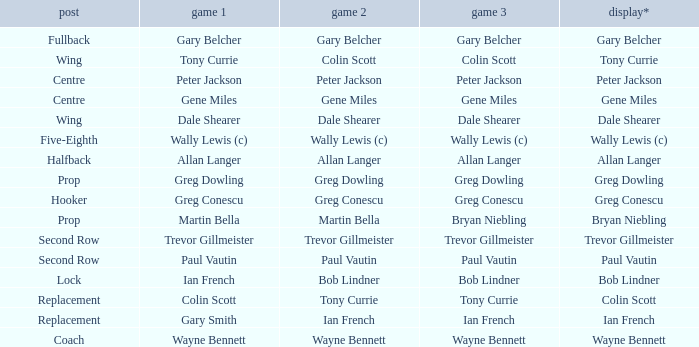What exhibition has greg conescu as game 1? Greg Conescu. 